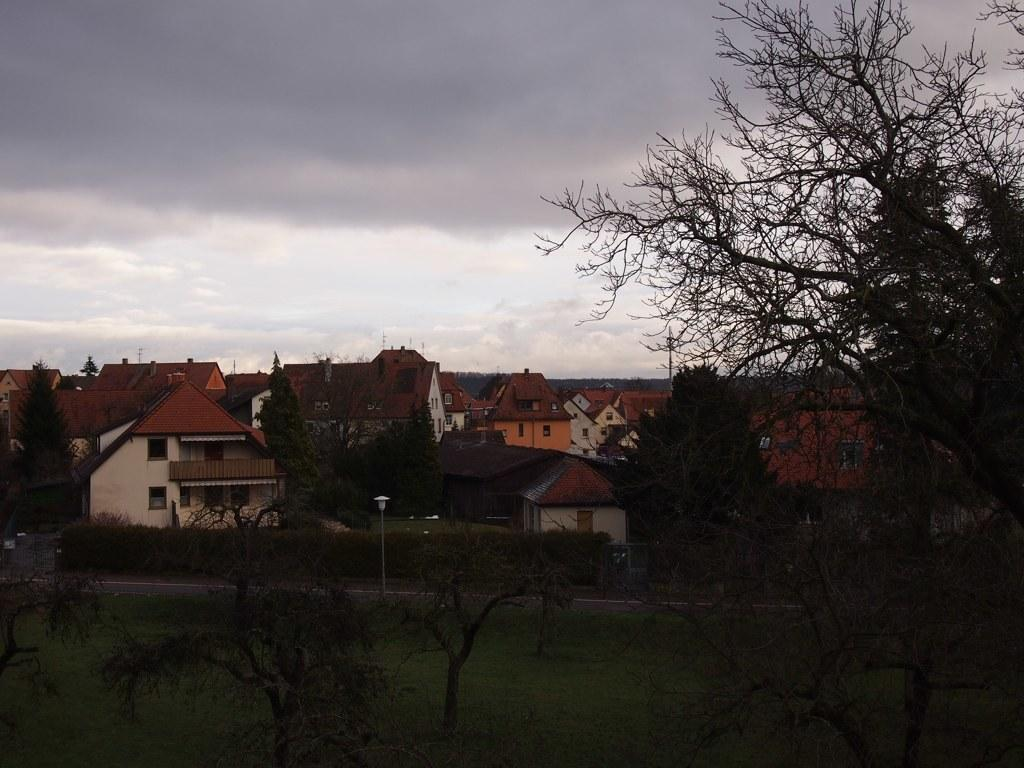What type of structures are visible in the image? There are houses with windows in the image. What other natural elements can be seen in the image? There are trees in the image. What is visible in the background of the image? The sky is visible in the image. What type of pen is being used by the band in the image? There is no pen or band present in the image. How many sticks are visible in the image? There are no sticks visible in the image. 